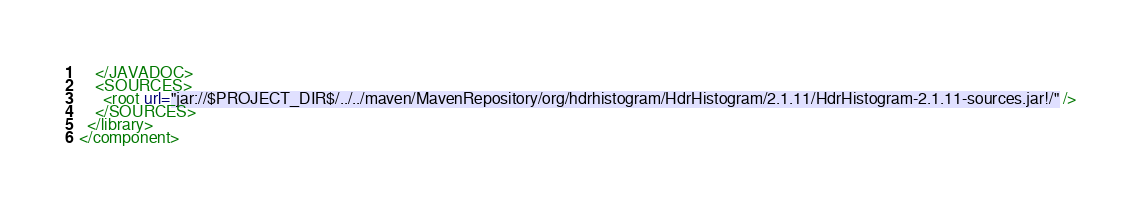<code> <loc_0><loc_0><loc_500><loc_500><_XML_>    </JAVADOC>
    <SOURCES>
      <root url="jar://$PROJECT_DIR$/../../maven/MavenRepository/org/hdrhistogram/HdrHistogram/2.1.11/HdrHistogram-2.1.11-sources.jar!/" />
    </SOURCES>
  </library>
</component></code> 